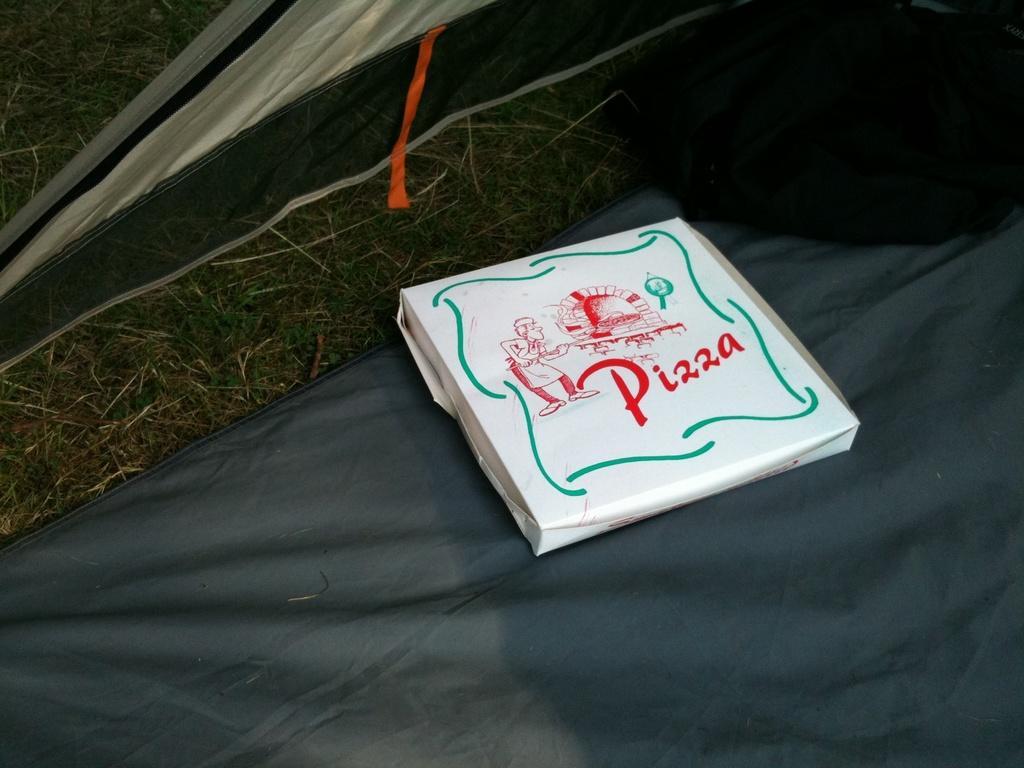In one or two sentences, can you explain what this image depicts? In this image we can see a cardboard carton placed on the ground. 